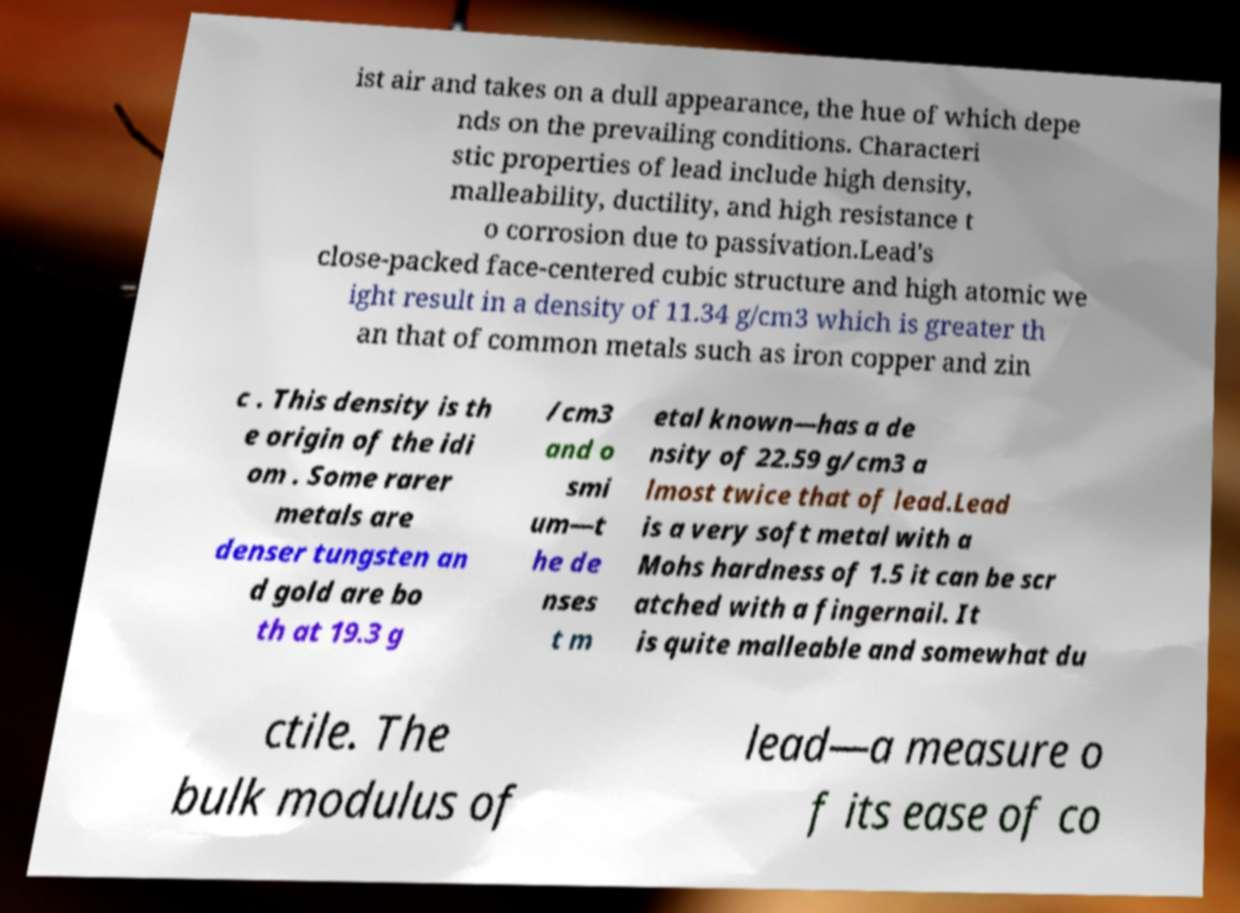There's text embedded in this image that I need extracted. Can you transcribe it verbatim? ist air and takes on a dull appearance, the hue of which depe nds on the prevailing conditions. Characteri stic properties of lead include high density, malleability, ductility, and high resistance t o corrosion due to passivation.Lead's close-packed face-centered cubic structure and high atomic we ight result in a density of 11.34 g/cm3 which is greater th an that of common metals such as iron copper and zin c . This density is th e origin of the idi om . Some rarer metals are denser tungsten an d gold are bo th at 19.3 g /cm3 and o smi um—t he de nses t m etal known—has a de nsity of 22.59 g/cm3 a lmost twice that of lead.Lead is a very soft metal with a Mohs hardness of 1.5 it can be scr atched with a fingernail. It is quite malleable and somewhat du ctile. The bulk modulus of lead—a measure o f its ease of co 